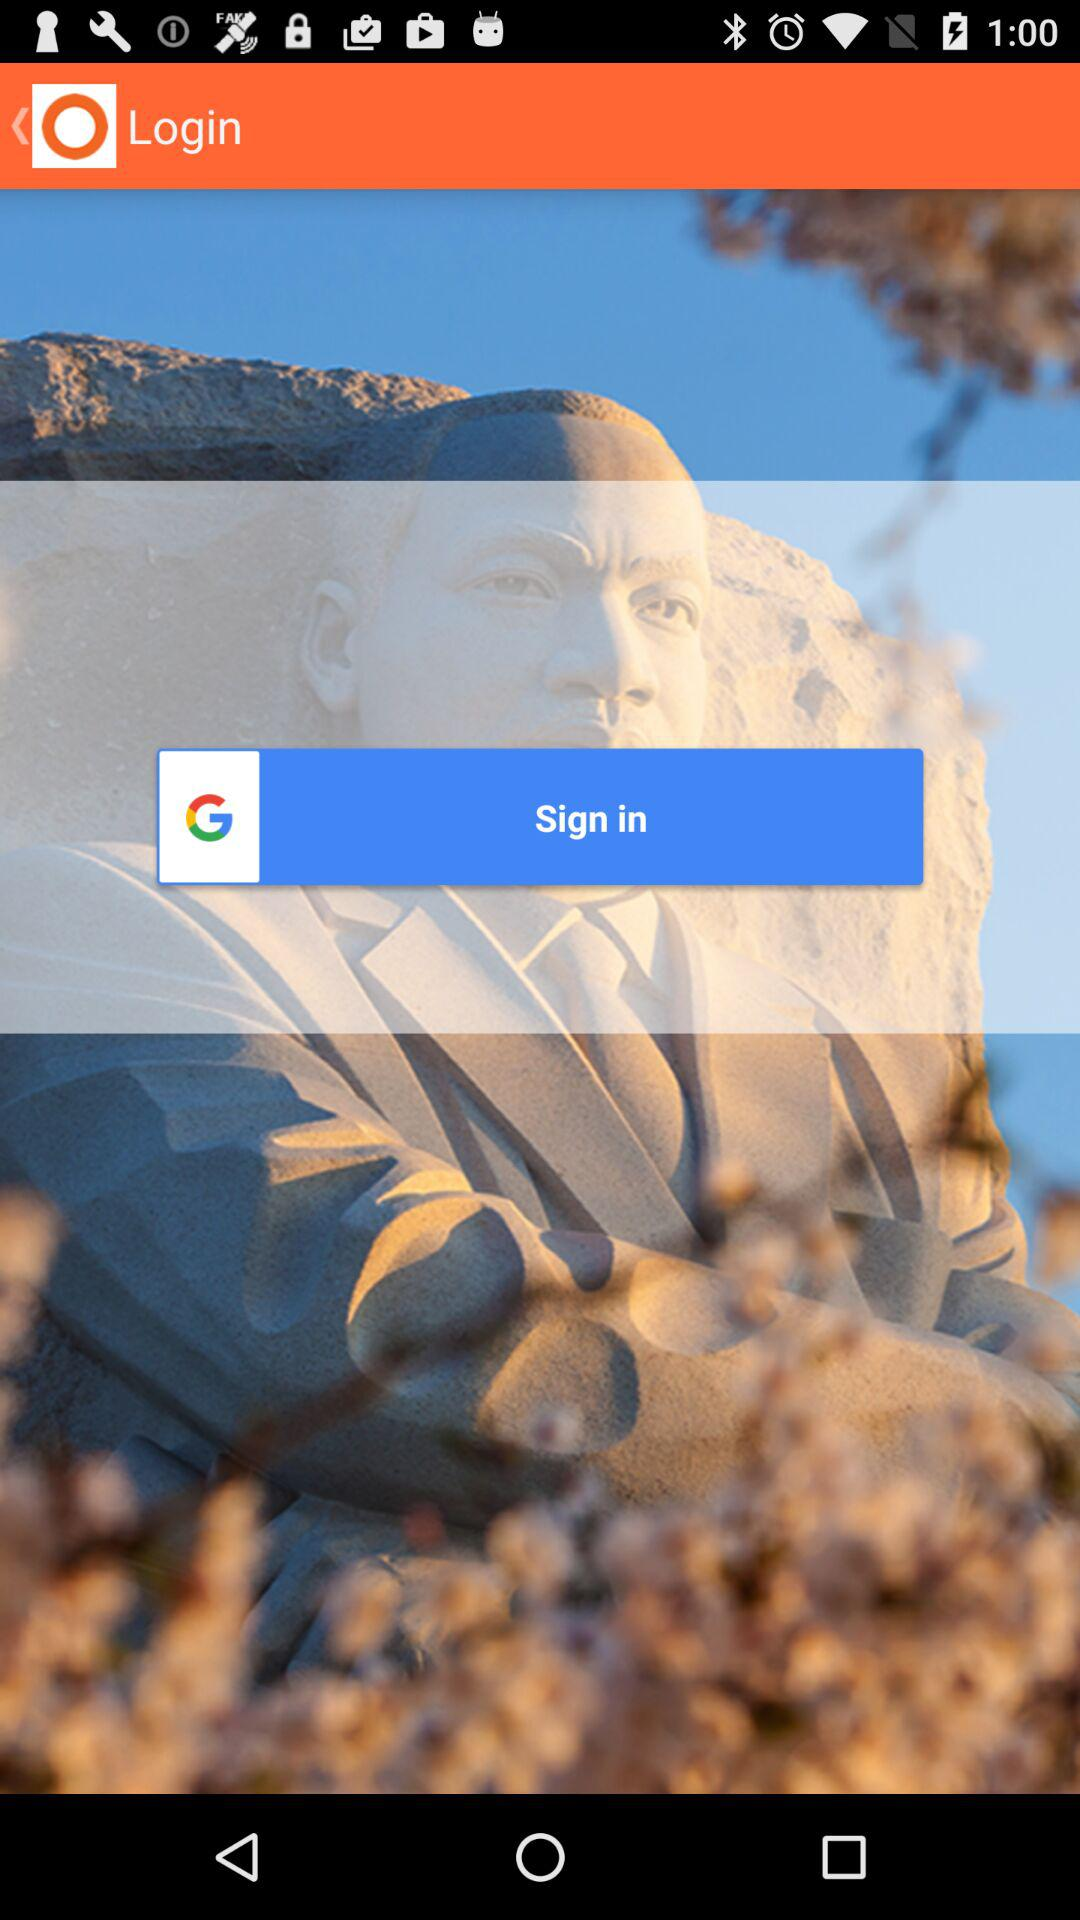Through what application can we log in? You can log in with "Google". 